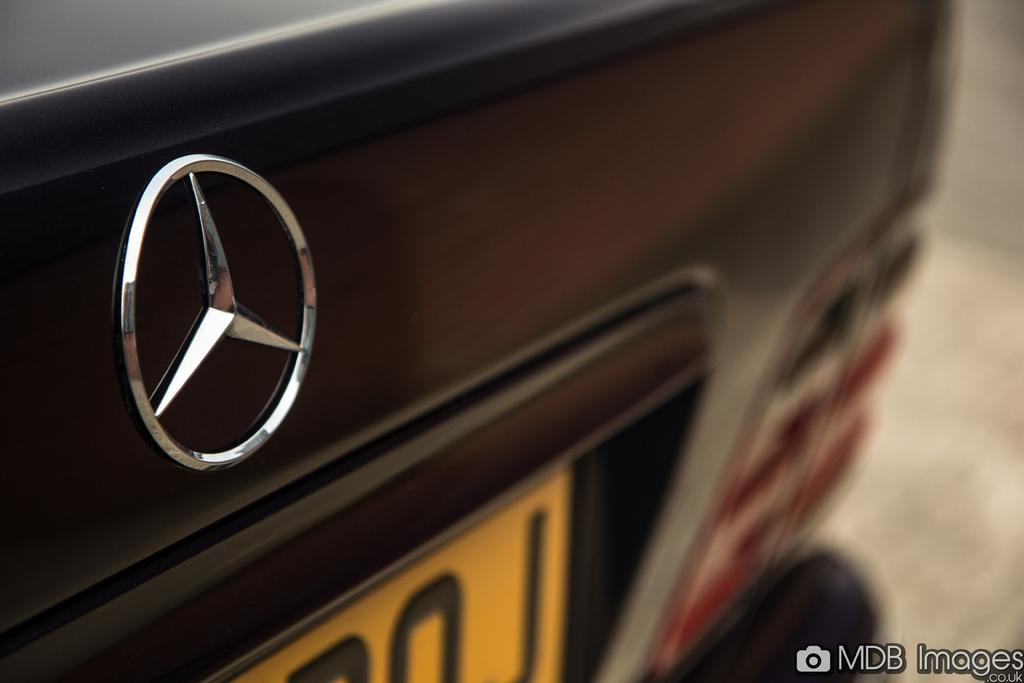What can be seen in the image that represents a brand or company? There is a logo in the image. What else is present in the image that might provide identifying information? There is a number plate on a vehicle in the image. How would you describe the overall clarity of the image? The background of the image is blurry. Where can some additional information be found in the image? There is some text in the bottom right corner of the image. What type of hall is depicted in the image? There is no hall present in the image; it features a logo, a number plate on a vehicle, a blurry background, and some text in the bottom right corner. 